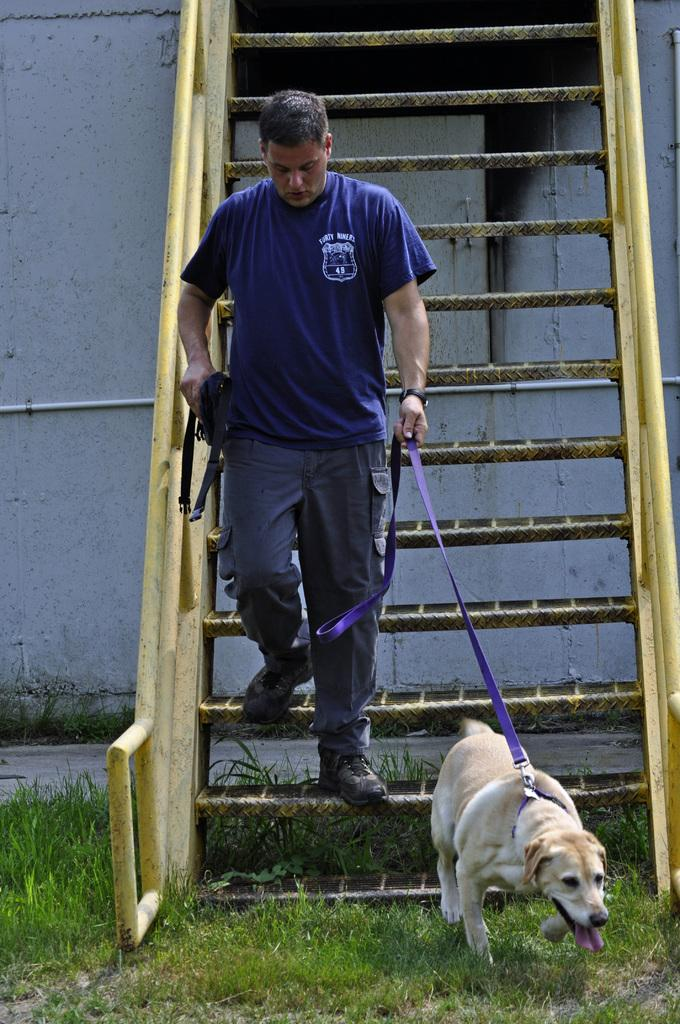What is present in the image? There is a man and a dog in the image. Where are the man and the dog located? The man and the dog are on a set of stairs. Can you see any waves in the image? There are no waves present in the image. Is the dog biting the man's stomach in the image? There is no indication in the image that the dog is biting the man's stomach. 